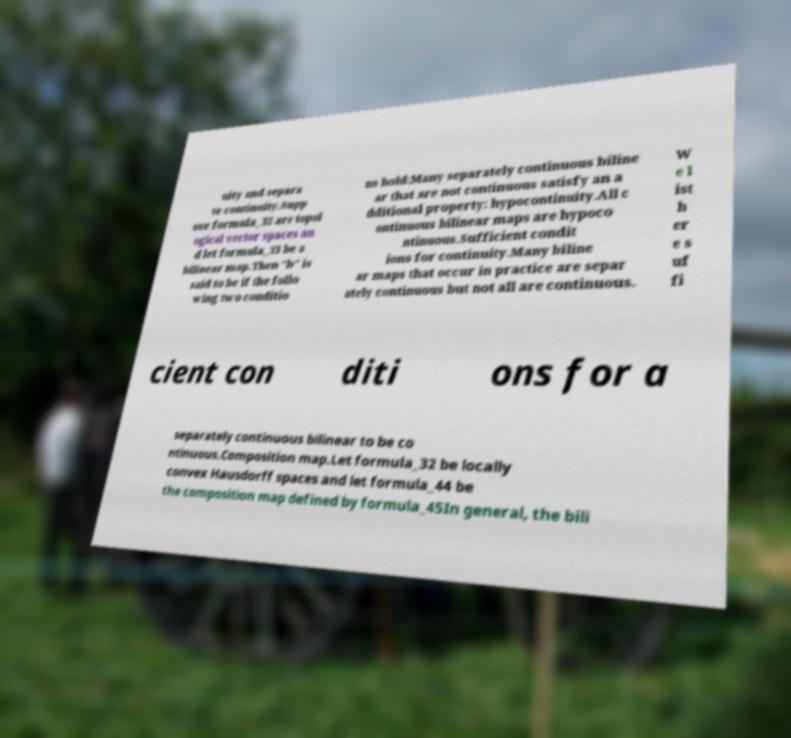Please read and relay the text visible in this image. What does it say? uity and separa te continuity.Supp ose formula_32 are topol ogical vector spaces an d let formula_33 be a bilinear map.Then "b" is said to be if the follo wing two conditio ns hold:Many separately continuous biline ar that are not continuous satisfy an a dditional property: hypocontinuity.All c ontinuous bilinear maps are hypoco ntinuous.Sufficient condit ions for continuity.Many biline ar maps that occur in practice are separ ately continuous but not all are continuous. W e l ist h er e s uf fi cient con diti ons for a separately continuous bilinear to be co ntinuous.Composition map.Let formula_32 be locally convex Hausdorff spaces and let formula_44 be the composition map defined by formula_45In general, the bili 